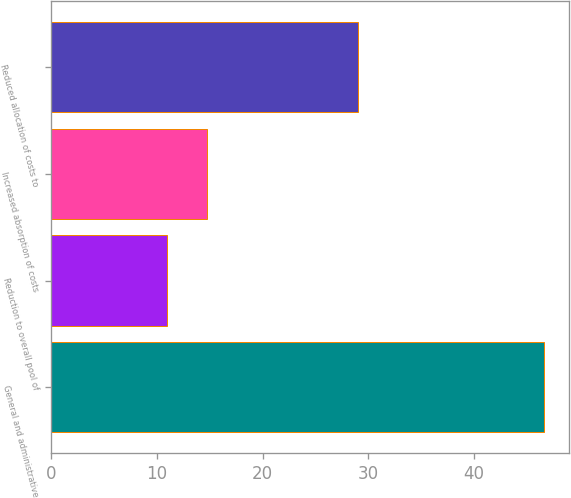Convert chart to OTSL. <chart><loc_0><loc_0><loc_500><loc_500><bar_chart><fcel>General and administrative<fcel>Reduction to overall pool of<fcel>Increased absorption of costs<fcel>Reduced allocation of costs to<nl><fcel>46.64<fcel>11<fcel>14.7<fcel>29<nl></chart> 